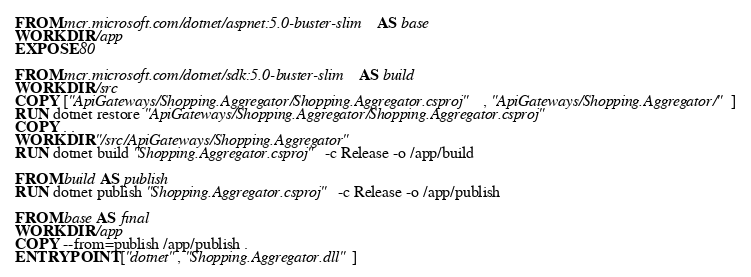<code> <loc_0><loc_0><loc_500><loc_500><_Dockerfile_>
FROM mcr.microsoft.com/dotnet/aspnet:5.0-buster-slim AS base
WORKDIR /app
EXPOSE 80

FROM mcr.microsoft.com/dotnet/sdk:5.0-buster-slim AS build
WORKDIR /src
COPY ["ApiGateways/Shopping.Aggregator/Shopping.Aggregator.csproj", "ApiGateways/Shopping.Aggregator/"]
RUN dotnet restore "ApiGateways/Shopping.Aggregator/Shopping.Aggregator.csproj"
COPY . .
WORKDIR "/src/ApiGateways/Shopping.Aggregator"
RUN dotnet build "Shopping.Aggregator.csproj" -c Release -o /app/build

FROM build AS publish
RUN dotnet publish "Shopping.Aggregator.csproj" -c Release -o /app/publish

FROM base AS final
WORKDIR /app
COPY --from=publish /app/publish .
ENTRYPOINT ["dotnet", "Shopping.Aggregator.dll"]</code> 